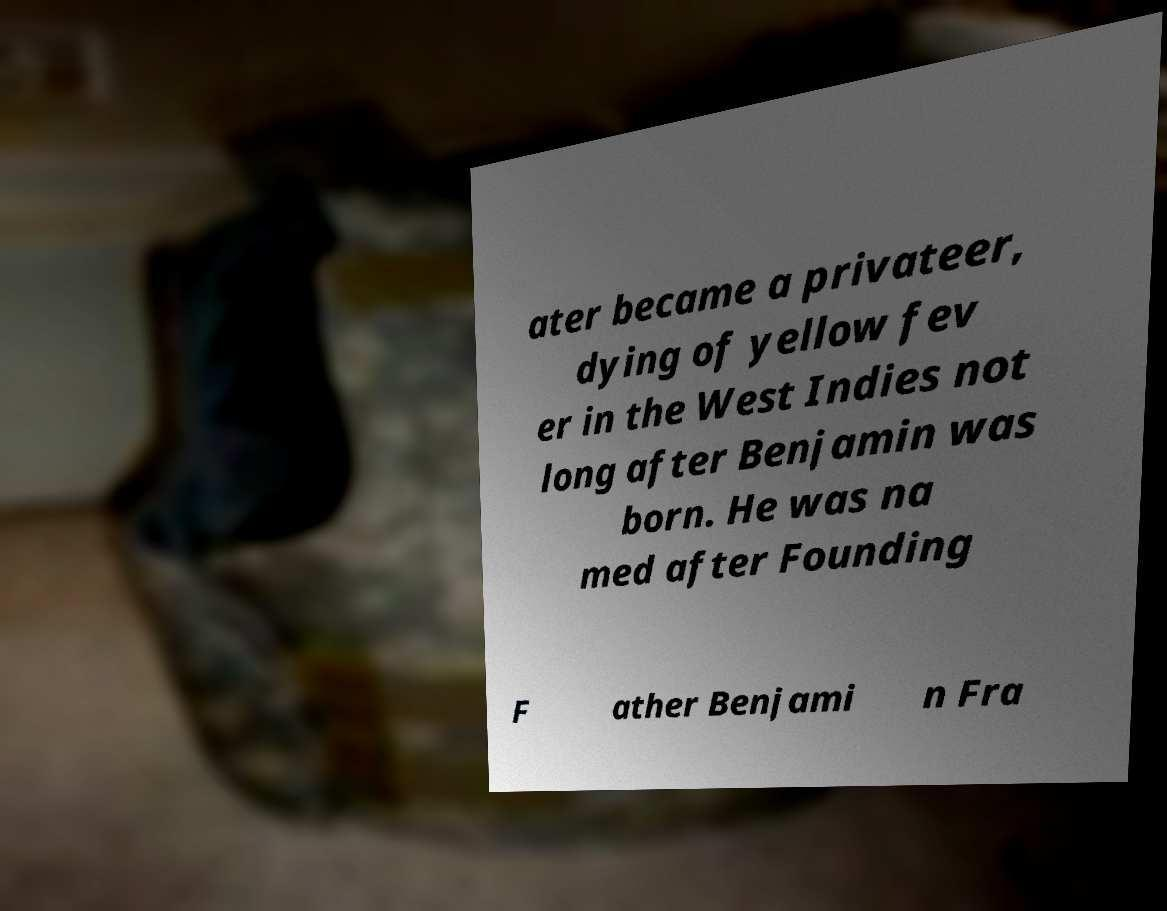Could you assist in decoding the text presented in this image and type it out clearly? ater became a privateer, dying of yellow fev er in the West Indies not long after Benjamin was born. He was na med after Founding F ather Benjami n Fra 